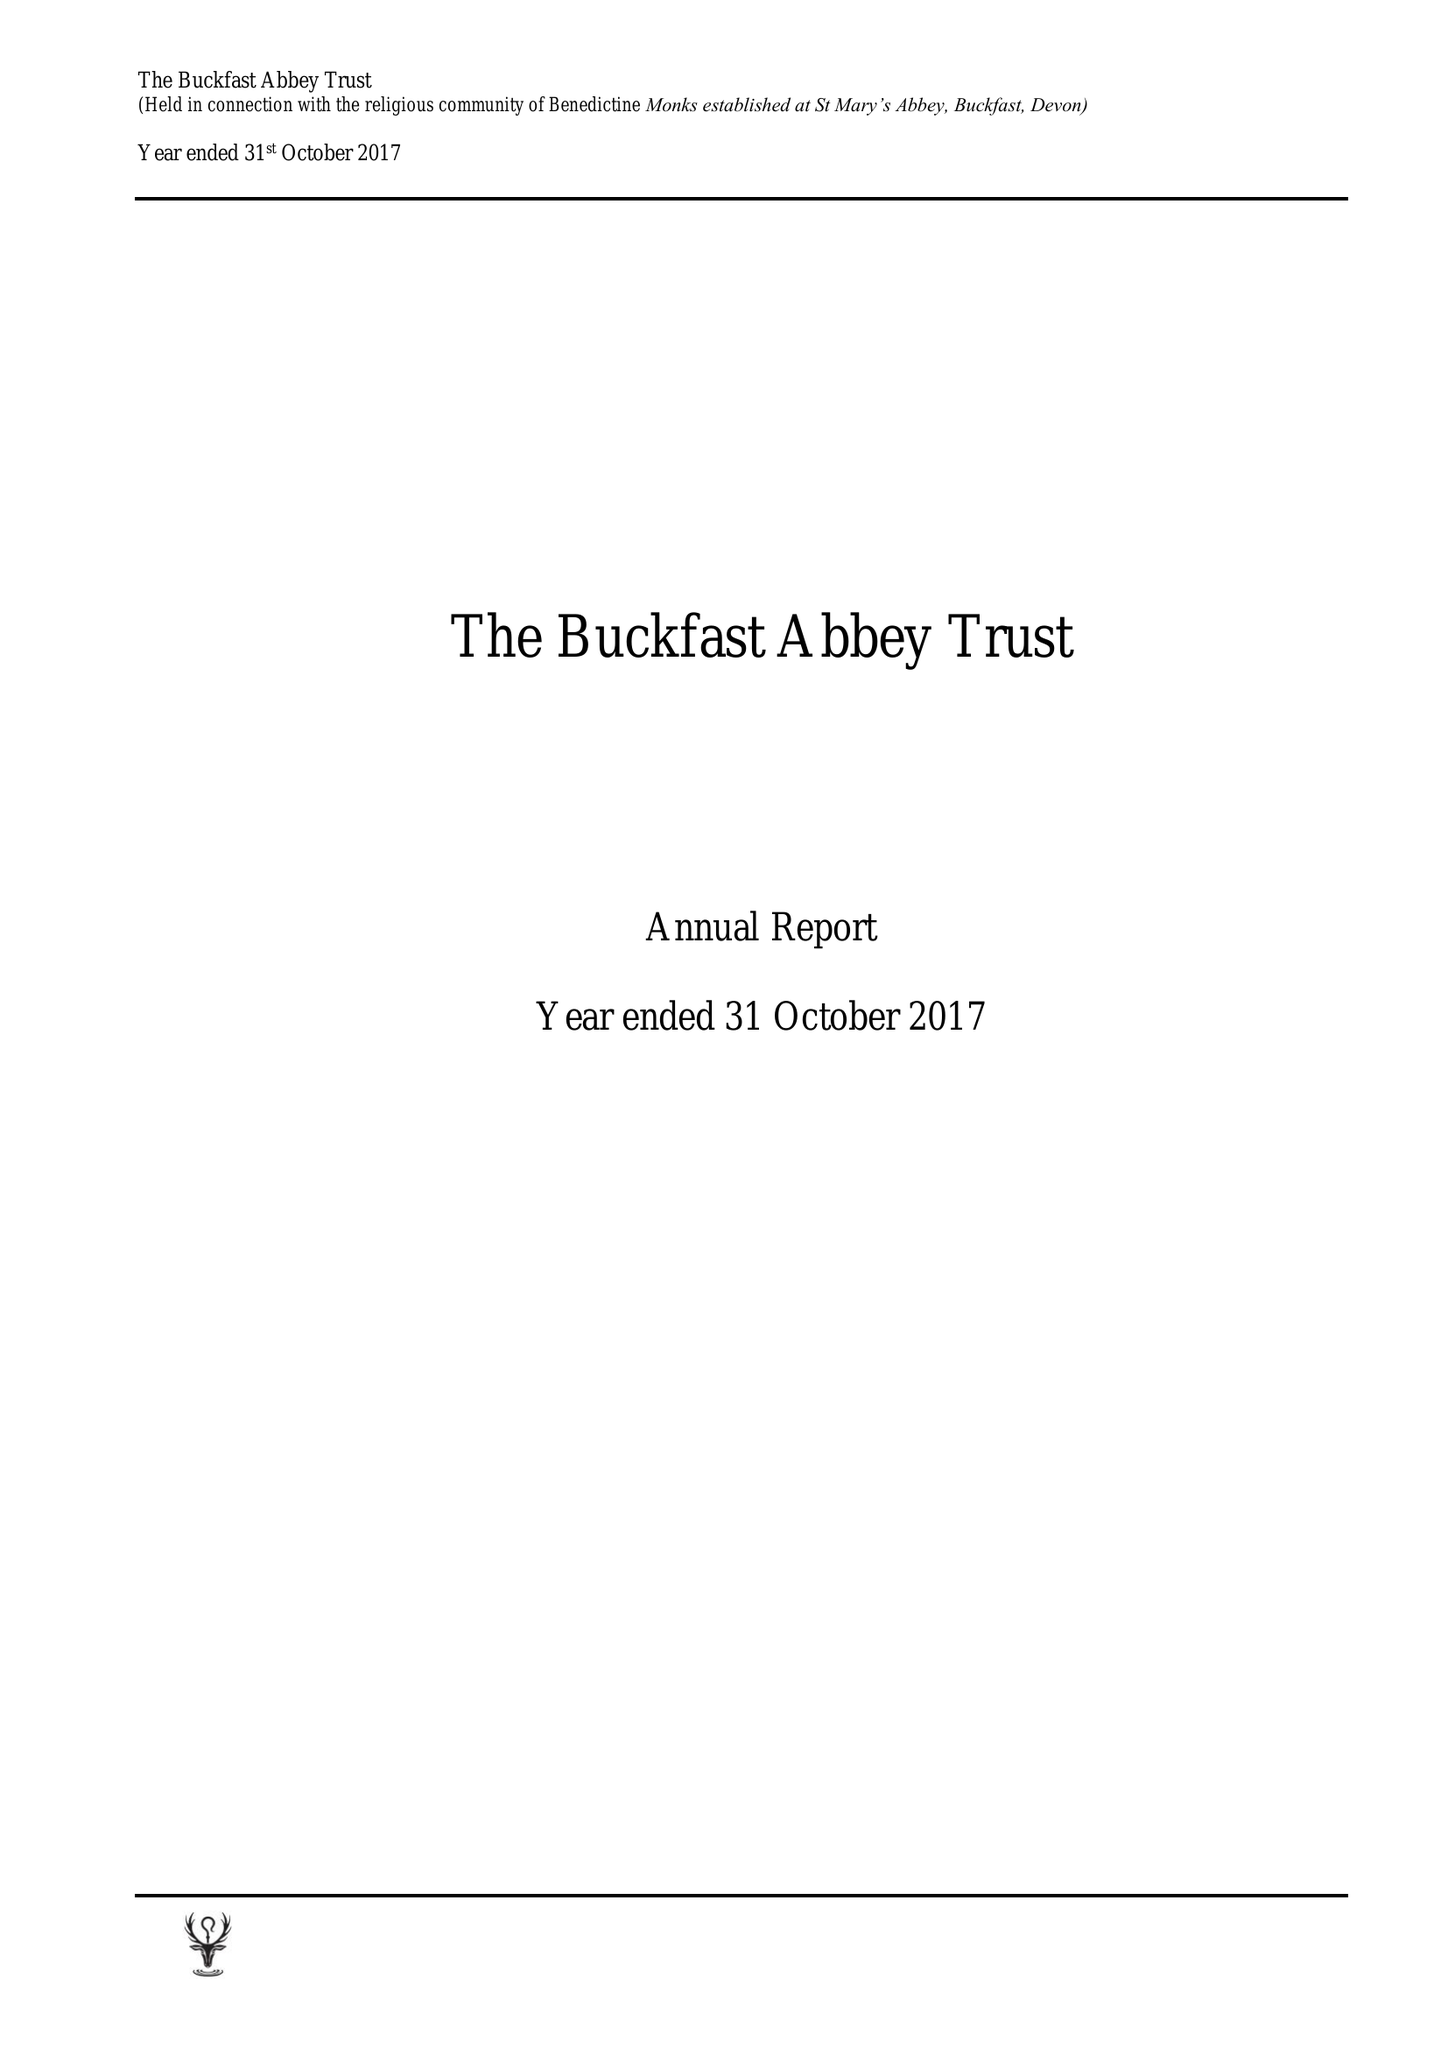What is the value for the address__post_town?
Answer the question using a single word or phrase. BUCKFASTLEIGH 